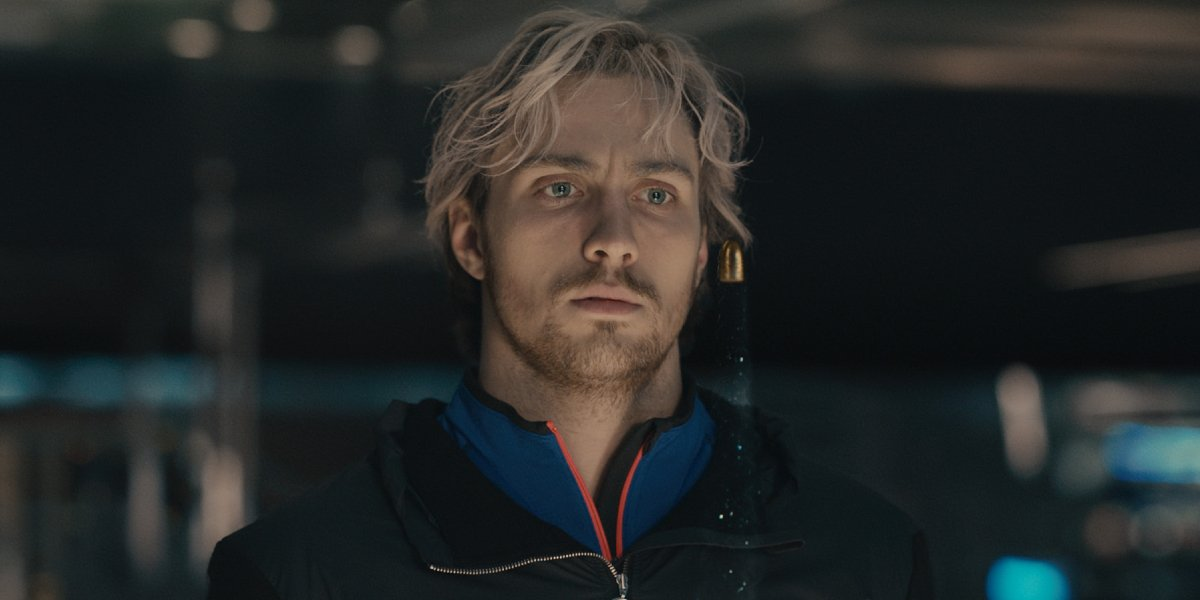Who might this person be waiting for? Given the man's serious and contemplative expression, he might be waiting for someone important to him. It could be a friend, a family member, or perhaps a significant other. The intensity of his gaze suggests that this meeting holds significant emotional weight for him. 